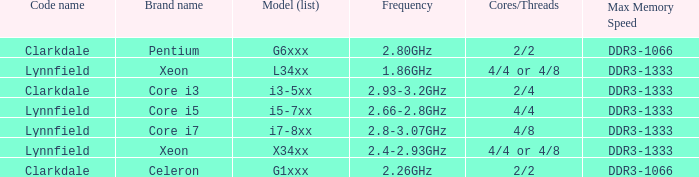List the number of cores for ddr3-1333 with frequencies between 2.66-2.8ghz. 4/4. 